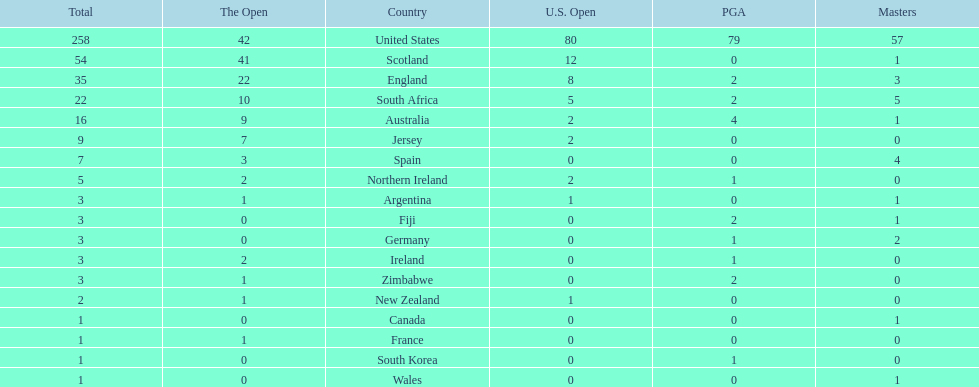How many countries have produced the same number of championship golfers as canada? 3. 